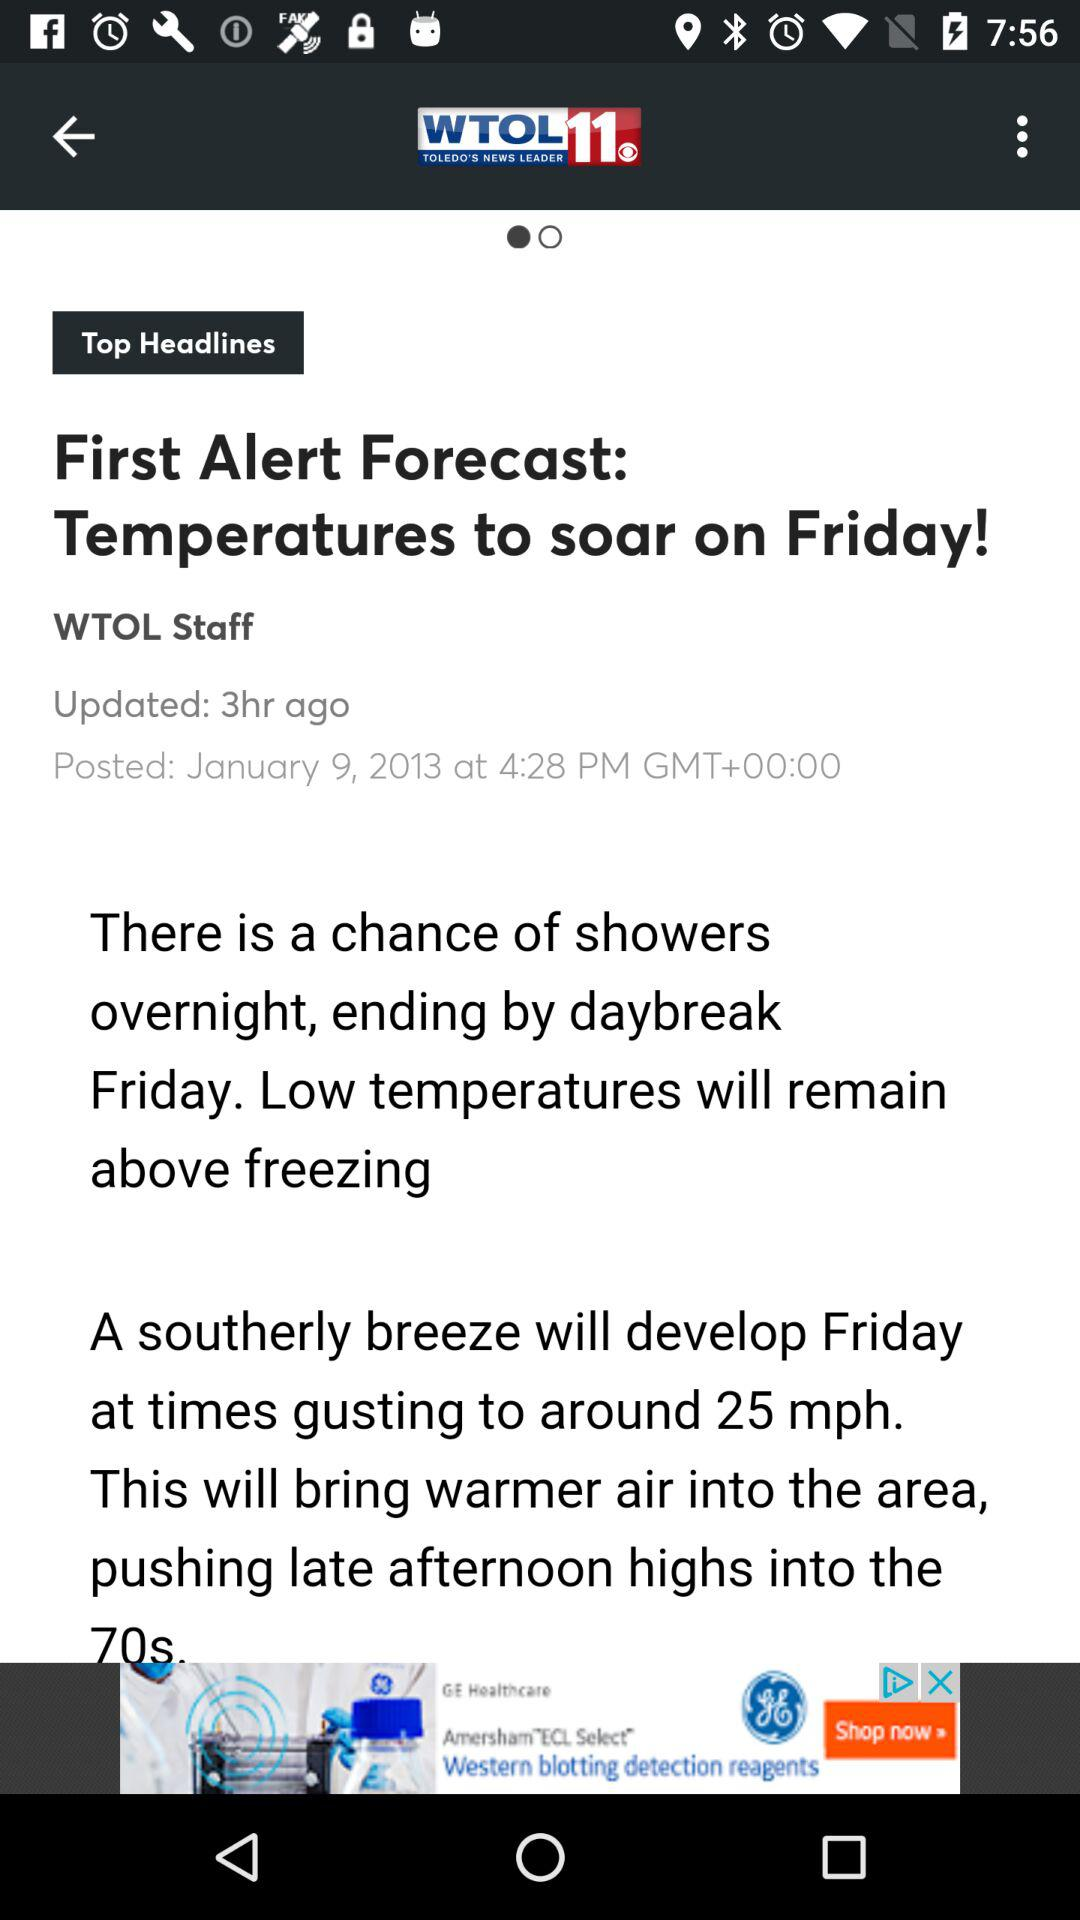Who is the author? The author is "WTOL Staff". 